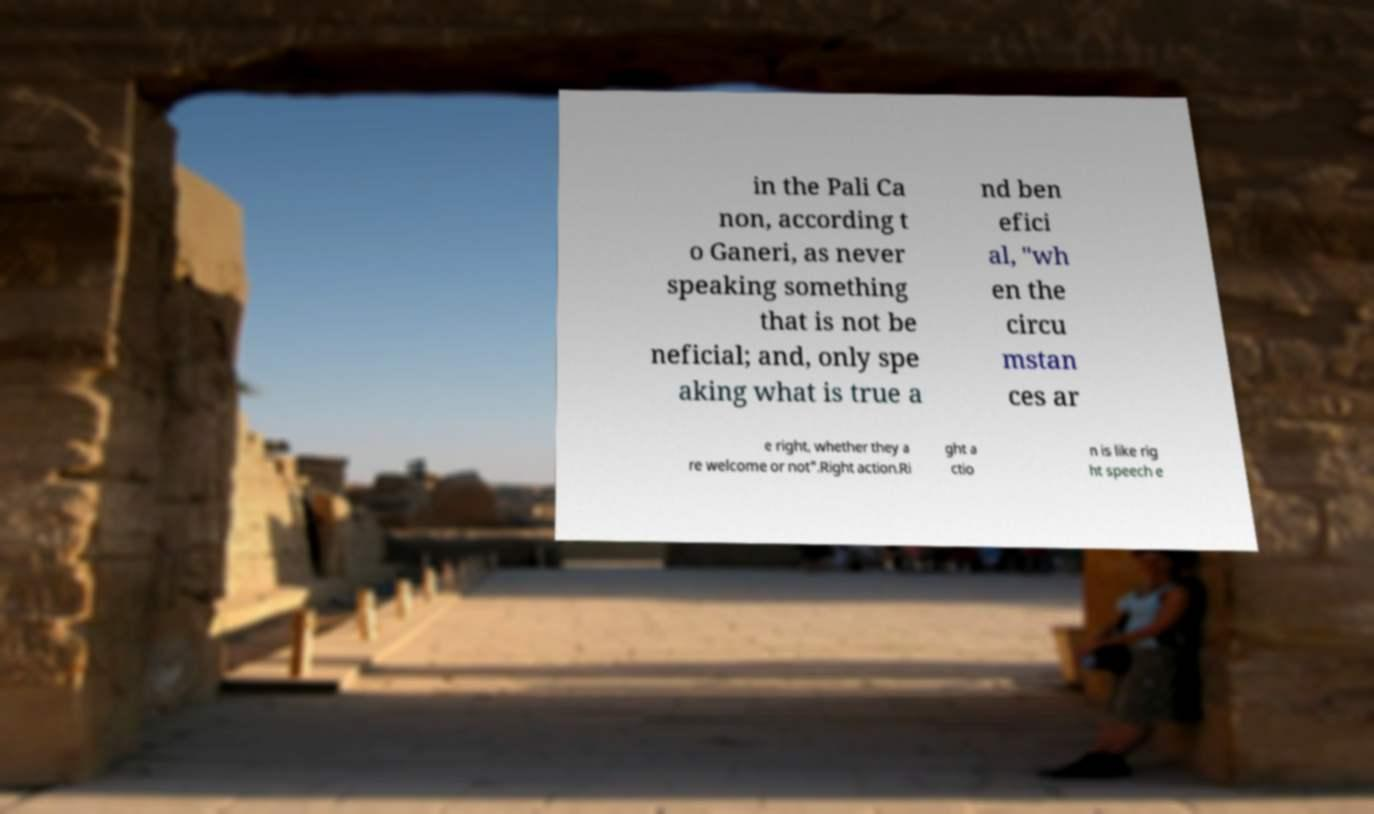What messages or text are displayed in this image? I need them in a readable, typed format. in the Pali Ca non, according t o Ganeri, as never speaking something that is not be neficial; and, only spe aking what is true a nd ben efici al, "wh en the circu mstan ces ar e right, whether they a re welcome or not".Right action.Ri ght a ctio n is like rig ht speech e 